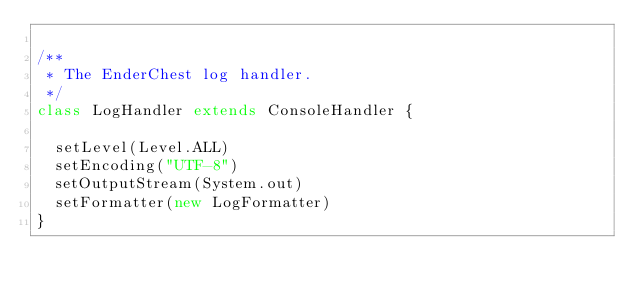Convert code to text. <code><loc_0><loc_0><loc_500><loc_500><_Scala_>
/**
 * The EnderChest log handler.
 */
class LogHandler extends ConsoleHandler {

  setLevel(Level.ALL)
  setEncoding("UTF-8")
  setOutputStream(System.out)
  setFormatter(new LogFormatter)
}</code> 